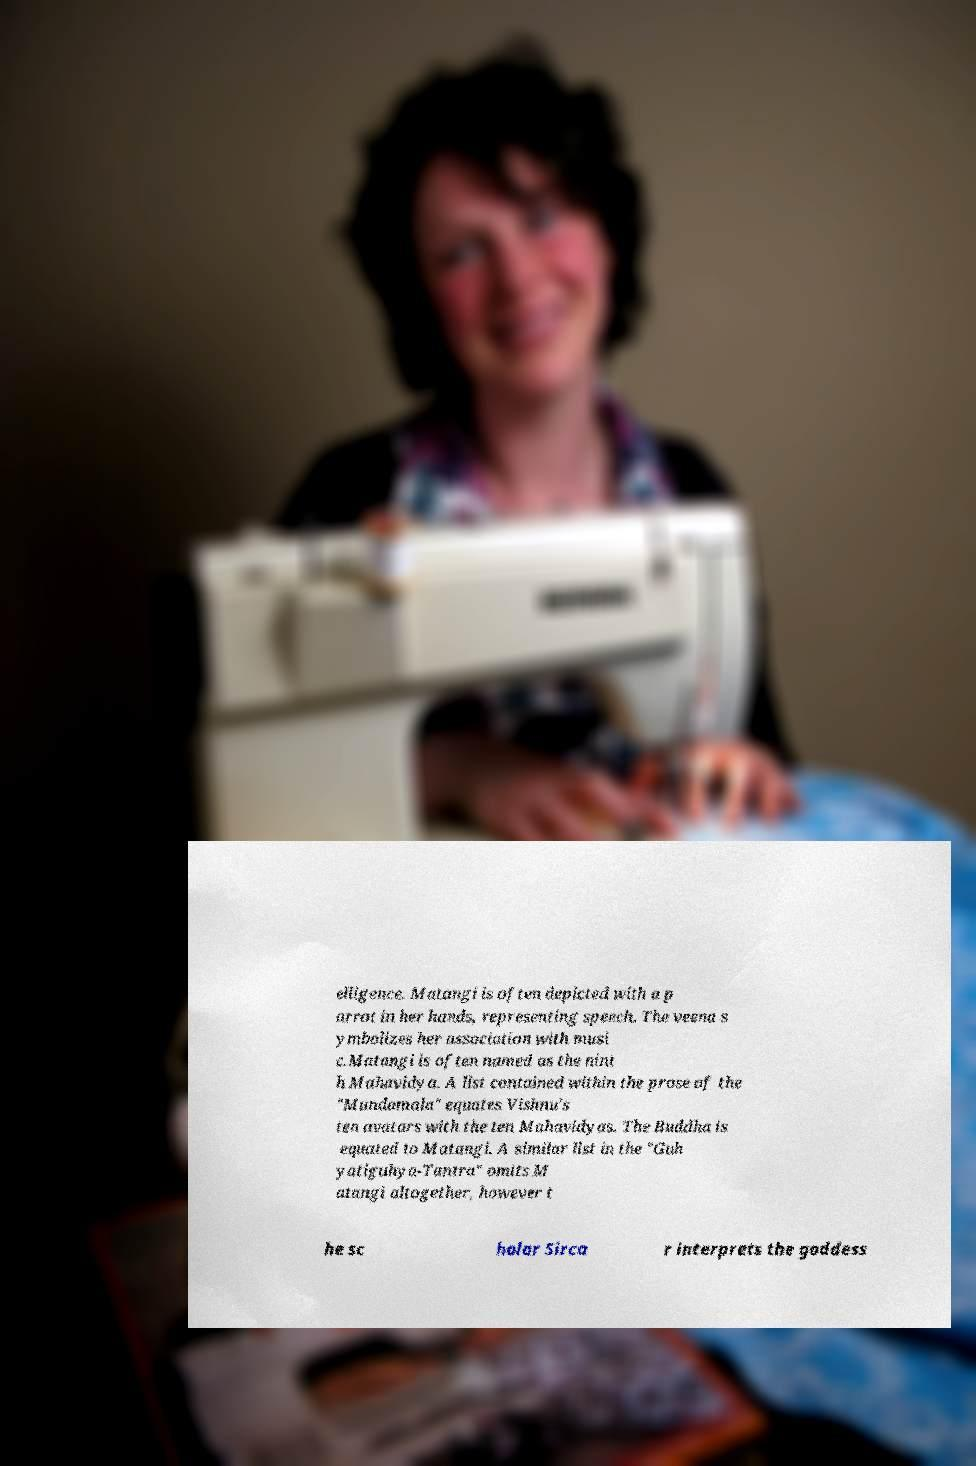There's text embedded in this image that I need extracted. Can you transcribe it verbatim? elligence. Matangi is often depicted with a p arrot in her hands, representing speech. The veena s ymbolizes her association with musi c.Matangi is often named as the nint h Mahavidya. A list contained within the prose of the "Mundamala" equates Vishnu's ten avatars with the ten Mahavidyas. The Buddha is equated to Matangi. A similar list in the "Guh yatiguhya-Tantra" omits M atangi altogether, however t he sc holar Sirca r interprets the goddess 